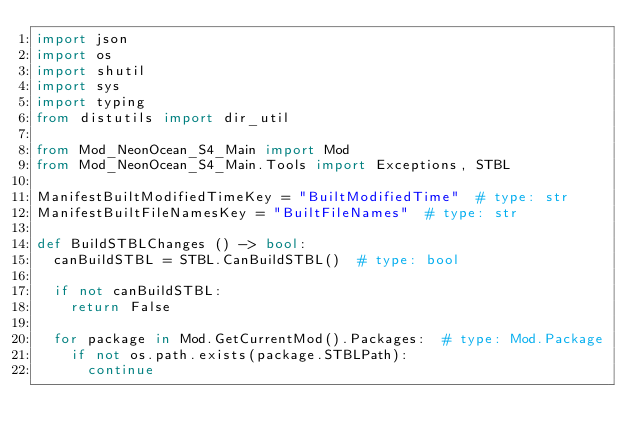<code> <loc_0><loc_0><loc_500><loc_500><_Python_>import json
import os
import shutil
import sys
import typing
from distutils import dir_util

from Mod_NeonOcean_S4_Main import Mod
from Mod_NeonOcean_S4_Main.Tools import Exceptions, STBL

ManifestBuiltModifiedTimeKey = "BuiltModifiedTime"  # type: str
ManifestBuiltFileNamesKey = "BuiltFileNames"  # type: str

def BuildSTBLChanges () -> bool:
	canBuildSTBL = STBL.CanBuildSTBL()  # type: bool

	if not canBuildSTBL:
		return False

	for package in Mod.GetCurrentMod().Packages:  # type: Mod.Package
		if not os.path.exists(package.STBLPath):
			continue
</code> 